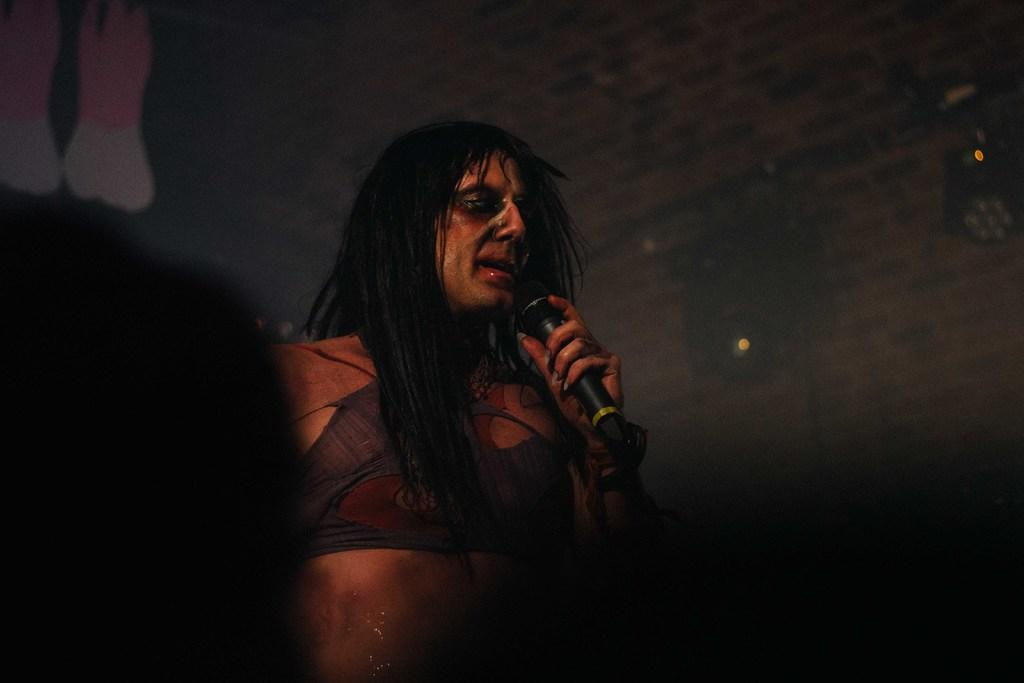Who is the main subject in the image? There is a man in the center of the image. What is the man wearing? The man is wearing a costume. What object is the man holding in his hand? The man is holding a microphone in his hand. What type of nut is the man holding in his hand instead of a microphone? The man is not holding a nut in his hand; he is holding a microphone. 